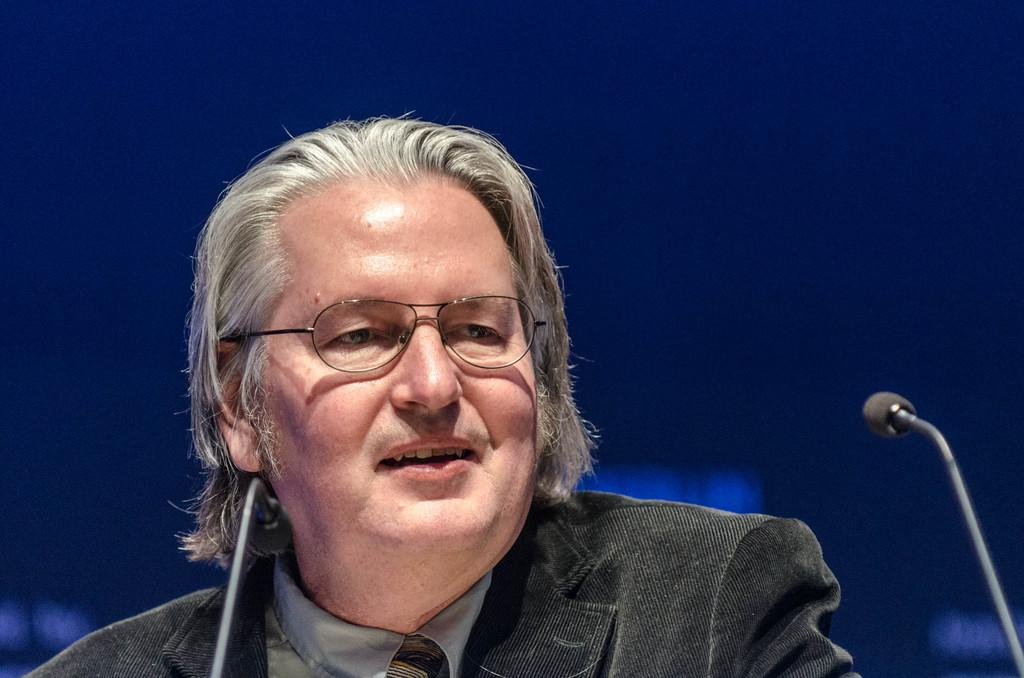Who is the person in the image? There is a man in the image. What is the man wearing? The man is wearing a coat and spectacles. What is the man's facial expression? The man is smiling. What objects are in front of the man? There are two microphones in front of the man. What color is the background of the image? The background of the image is blue. How many vases are visible in the image? There are no vases present in the image. What type of planes can be seen flying in the background of the image? There are no planes visible in the image; the background is blue. 